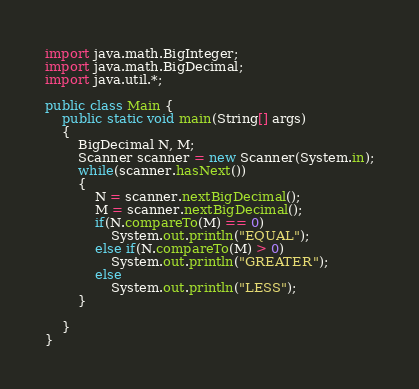<code> <loc_0><loc_0><loc_500><loc_500><_Java_>import java.math.BigInteger;
import java.math.BigDecimal;
import java.util.*;

public class Main {
	public static void main(String[] args)
	{
		BigDecimal N, M;
		Scanner scanner = new Scanner(System.in);
		while(scanner.hasNext())
		{
			N = scanner.nextBigDecimal();
			M = scanner.nextBigDecimal();
			if(N.compareTo(M) == 0) 
				System.out.println("EQUAL");
			else if(N.compareTo(M) > 0)
				System.out.println("GREATER");
			else 
				System.out.println("LESS");
		}
		
	}
}
</code> 